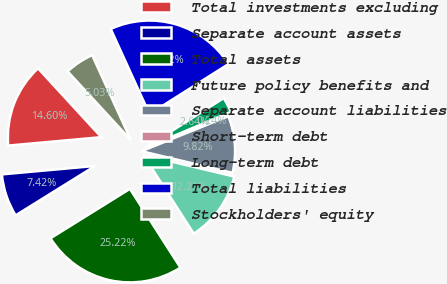Convert chart to OTSL. <chart><loc_0><loc_0><loc_500><loc_500><pie_chart><fcel>Total investments excluding<fcel>Separate account assets<fcel>Total assets<fcel>Future policy benefits and<fcel>Separate account liabilities<fcel>Short-term debt<fcel>Long-term debt<fcel>Total liabilities<fcel>Stockholders' equity<nl><fcel>14.6%<fcel>7.42%<fcel>25.22%<fcel>12.21%<fcel>9.82%<fcel>0.24%<fcel>2.64%<fcel>22.82%<fcel>5.03%<nl></chart> 